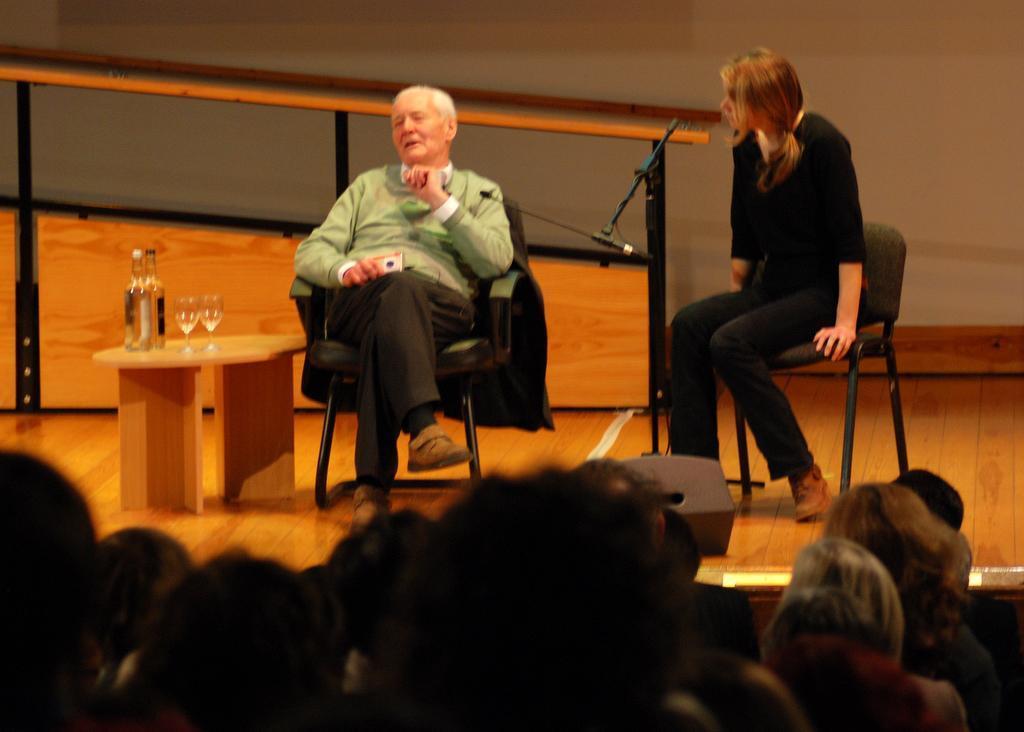Please provide a concise description of this image. This is the picture of a room. In this image there is a man sitting and talking and there is a woman sitting and there is microphone on the stage. There are two bottles and two glasses on the table and at the back there is a screen. In the foreground there are group of people. There is a speaker on the stage. 